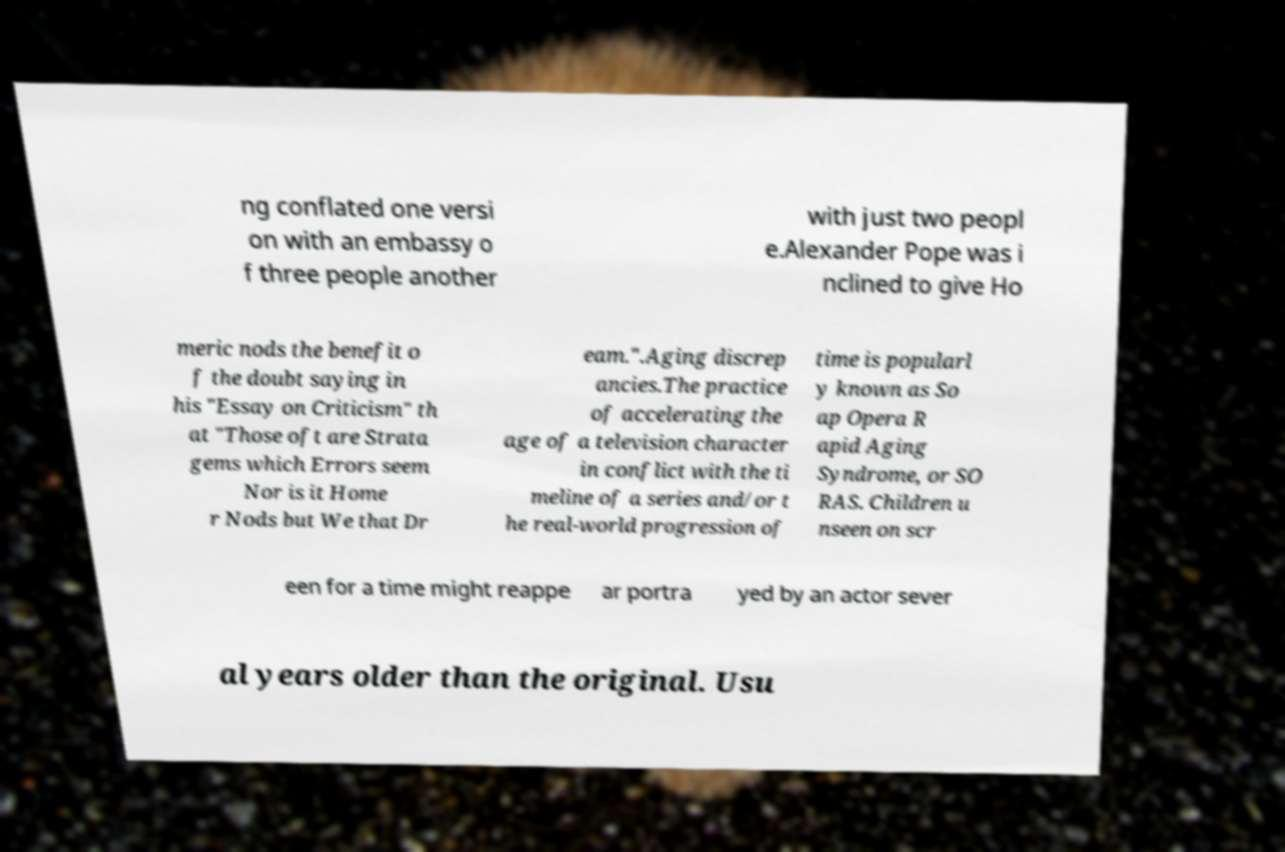Could you extract and type out the text from this image? ng conflated one versi on with an embassy o f three people another with just two peopl e.Alexander Pope was i nclined to give Ho meric nods the benefit o f the doubt saying in his "Essay on Criticism" th at "Those oft are Strata gems which Errors seem Nor is it Home r Nods but We that Dr eam.".Aging discrep ancies.The practice of accelerating the age of a television character in conflict with the ti meline of a series and/or t he real-world progression of time is popularl y known as So ap Opera R apid Aging Syndrome, or SO RAS. Children u nseen on scr een for a time might reappe ar portra yed by an actor sever al years older than the original. Usu 